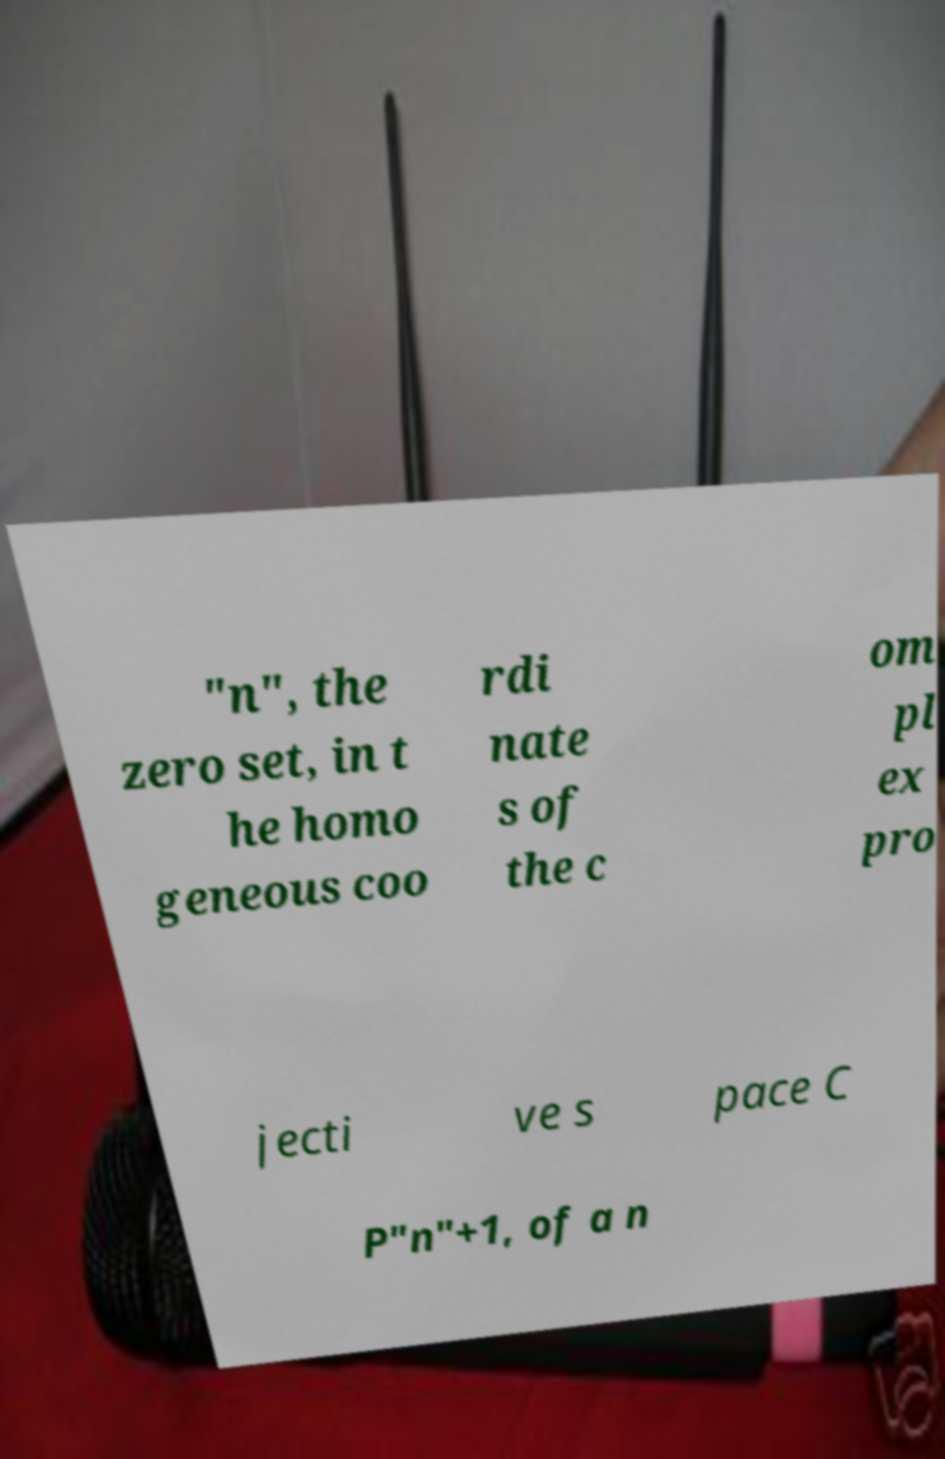What messages or text are displayed in this image? I need them in a readable, typed format. "n", the zero set, in t he homo geneous coo rdi nate s of the c om pl ex pro jecti ve s pace C P"n"+1, of a n 